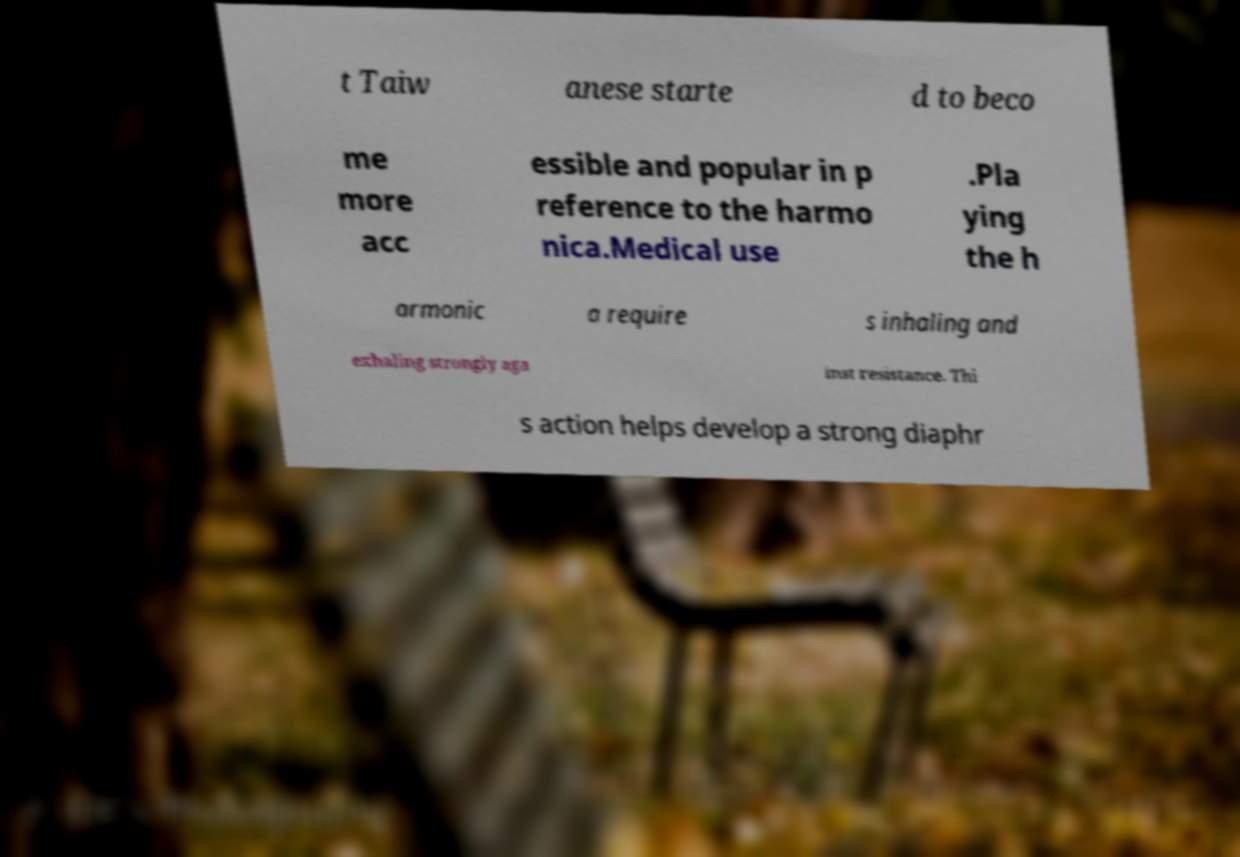For documentation purposes, I need the text within this image transcribed. Could you provide that? t Taiw anese starte d to beco me more acc essible and popular in p reference to the harmo nica.Medical use .Pla ying the h armonic a require s inhaling and exhaling strongly aga inst resistance. Thi s action helps develop a strong diaphr 